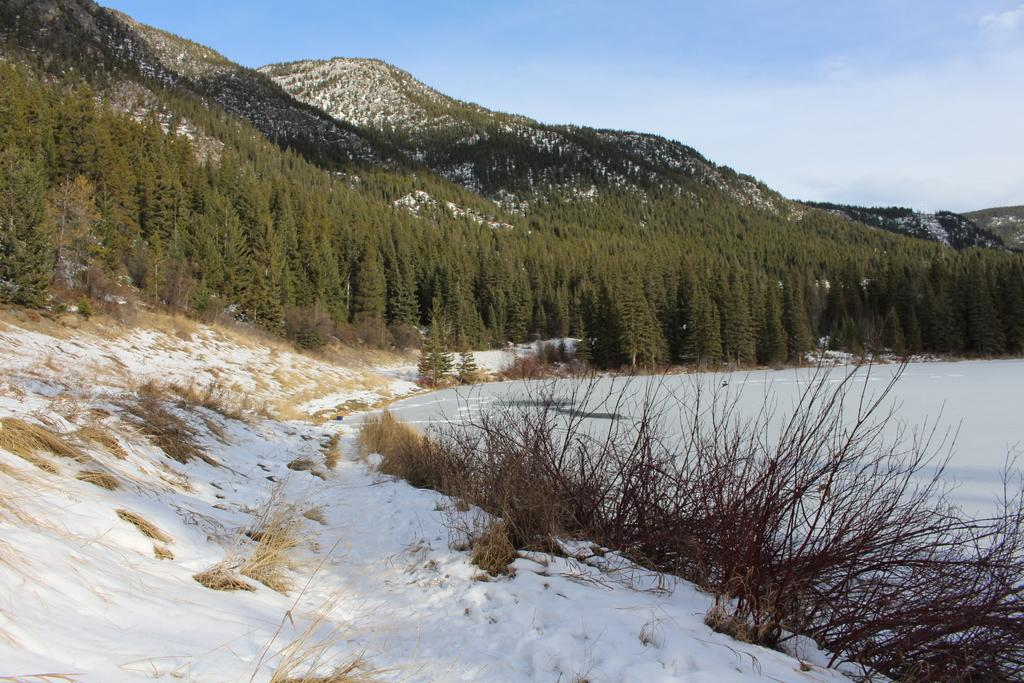What can be seen at the top of the image? The sky is visible towards the top of the image. What type of natural landforms are present in the image? There are mountains in the image. What type of vegetation can be seen in the image? There are trees and plants in the image. What is the condition of the ground in the image? There is ice on the ground in the image. What type of frame surrounds the image? There is no frame present in the image; it is a photograph or illustration without a visible frame. Can you tell me how many balloons are floating in the sky in the image? There are no balloons present in the image; it features mountains, trees, plants, and ice on the ground. 